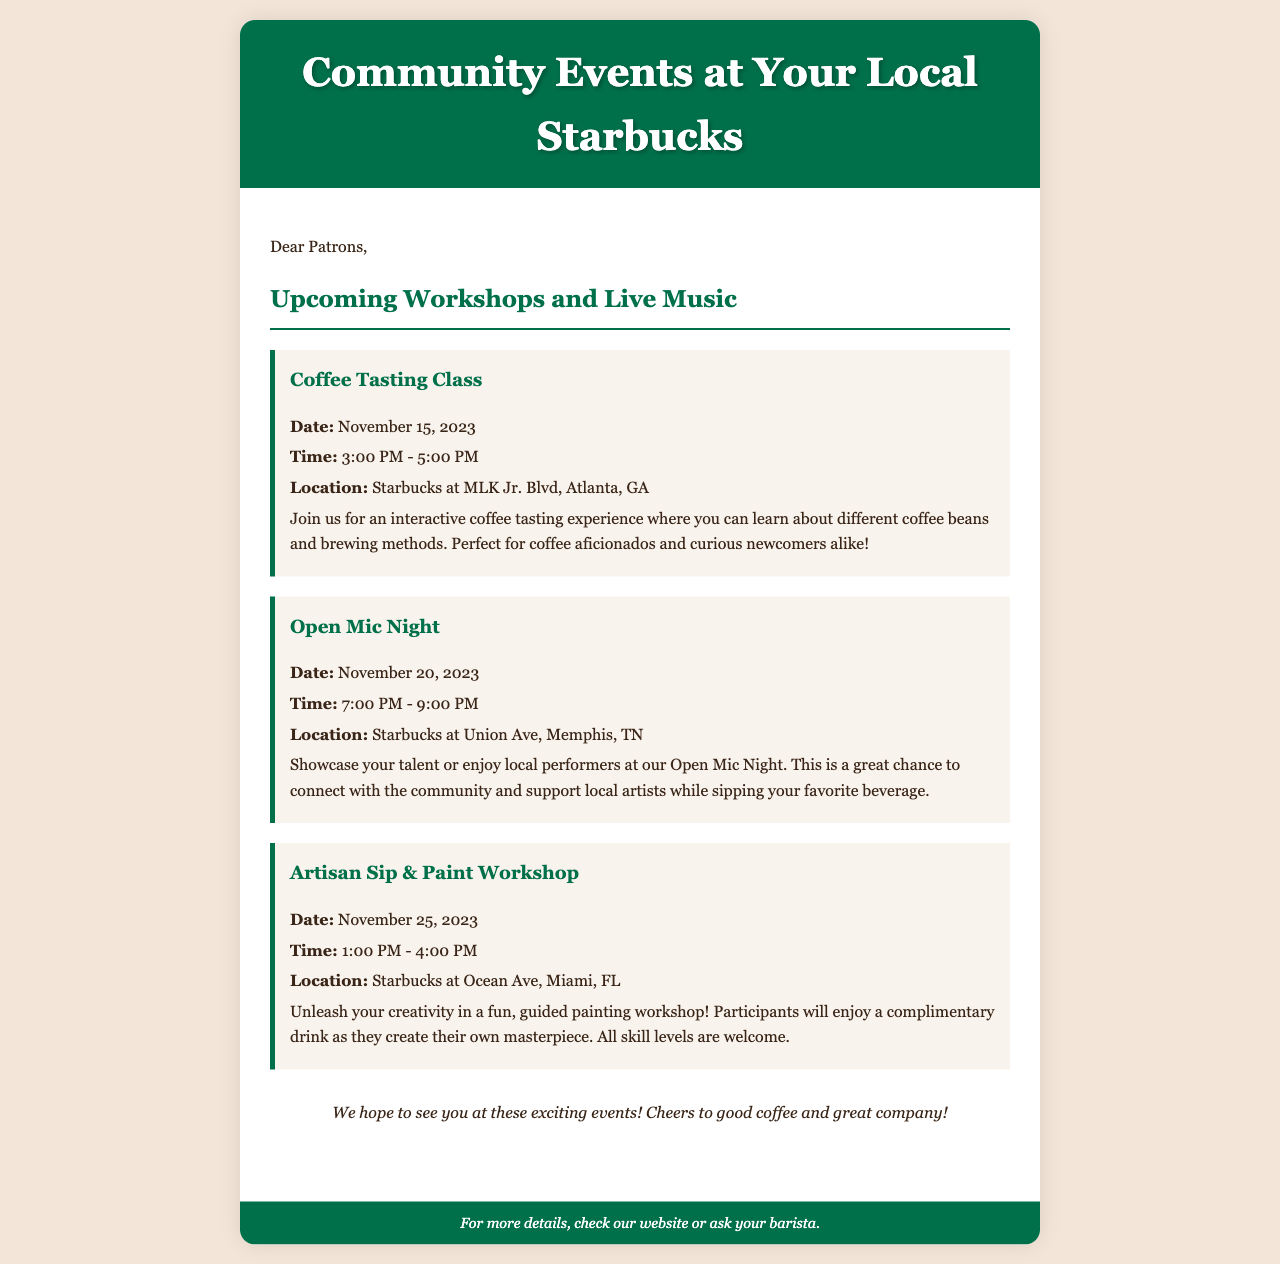what is the date of the Coffee Tasting Class? The date for the Coffee Tasting Class is specified in the event details section of the document.
Answer: November 15, 2023 what time does the Open Mic Night start? The start time for the Open Mic Night is included in the event description.
Answer: 7:00 PM which city is hosting the Artisan Sip & Paint Workshop? The city where the Artisan Sip & Paint Workshop takes place is mentioned in the location details of the event.
Answer: Miami, FL how long does the Coffee Tasting Class last? The duration of the Coffee Tasting Class can be found in the time section of the event details.
Answer: 2 hours what type of event is scheduled for November 20, 2023? The type of event is outlined in the event title for that date, indicating the nature of the gathering.
Answer: Open Mic Night which Starbucks location is hosting the Artisan Sip & Paint Workshop? The specific location for the Artisan Sip & Paint Workshop is stated in the event description.
Answer: Starbucks at Ocean Ave what can participants enjoy during the Artisan Sip & Paint Workshop? The benefits for participants are detailed in the description of the Artisan Sip & Paint Workshop.
Answer: A complimentary drink who can participate in the Coffee Tasting Class? The intended participants for the Coffee Tasting Class are described in the event details, suggesting an inclusive audience.
Answer: Coffee aficionados and curious newcomers what is the main focus of the Open Mic Night? The central theme or purpose of the Open Mic Night is explained in the event description.
Answer: Showcasing talent and supporting local artists 